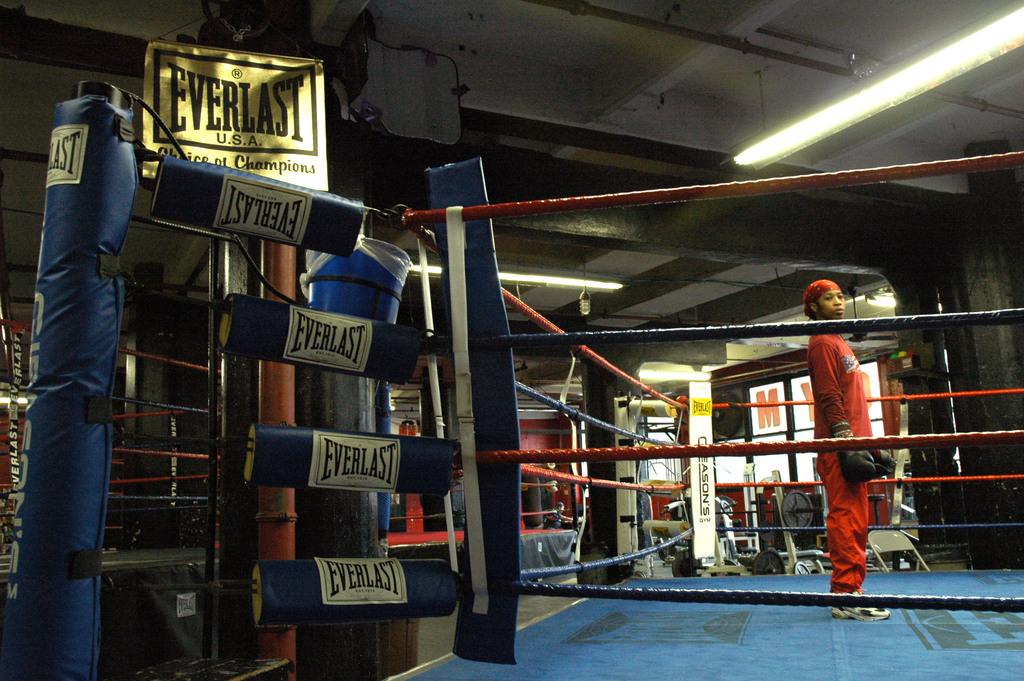What brand are the pads?
Your response must be concise. Everlast. How many people are in the ring?
Provide a succinct answer. Answering does not require reading text in the image. 